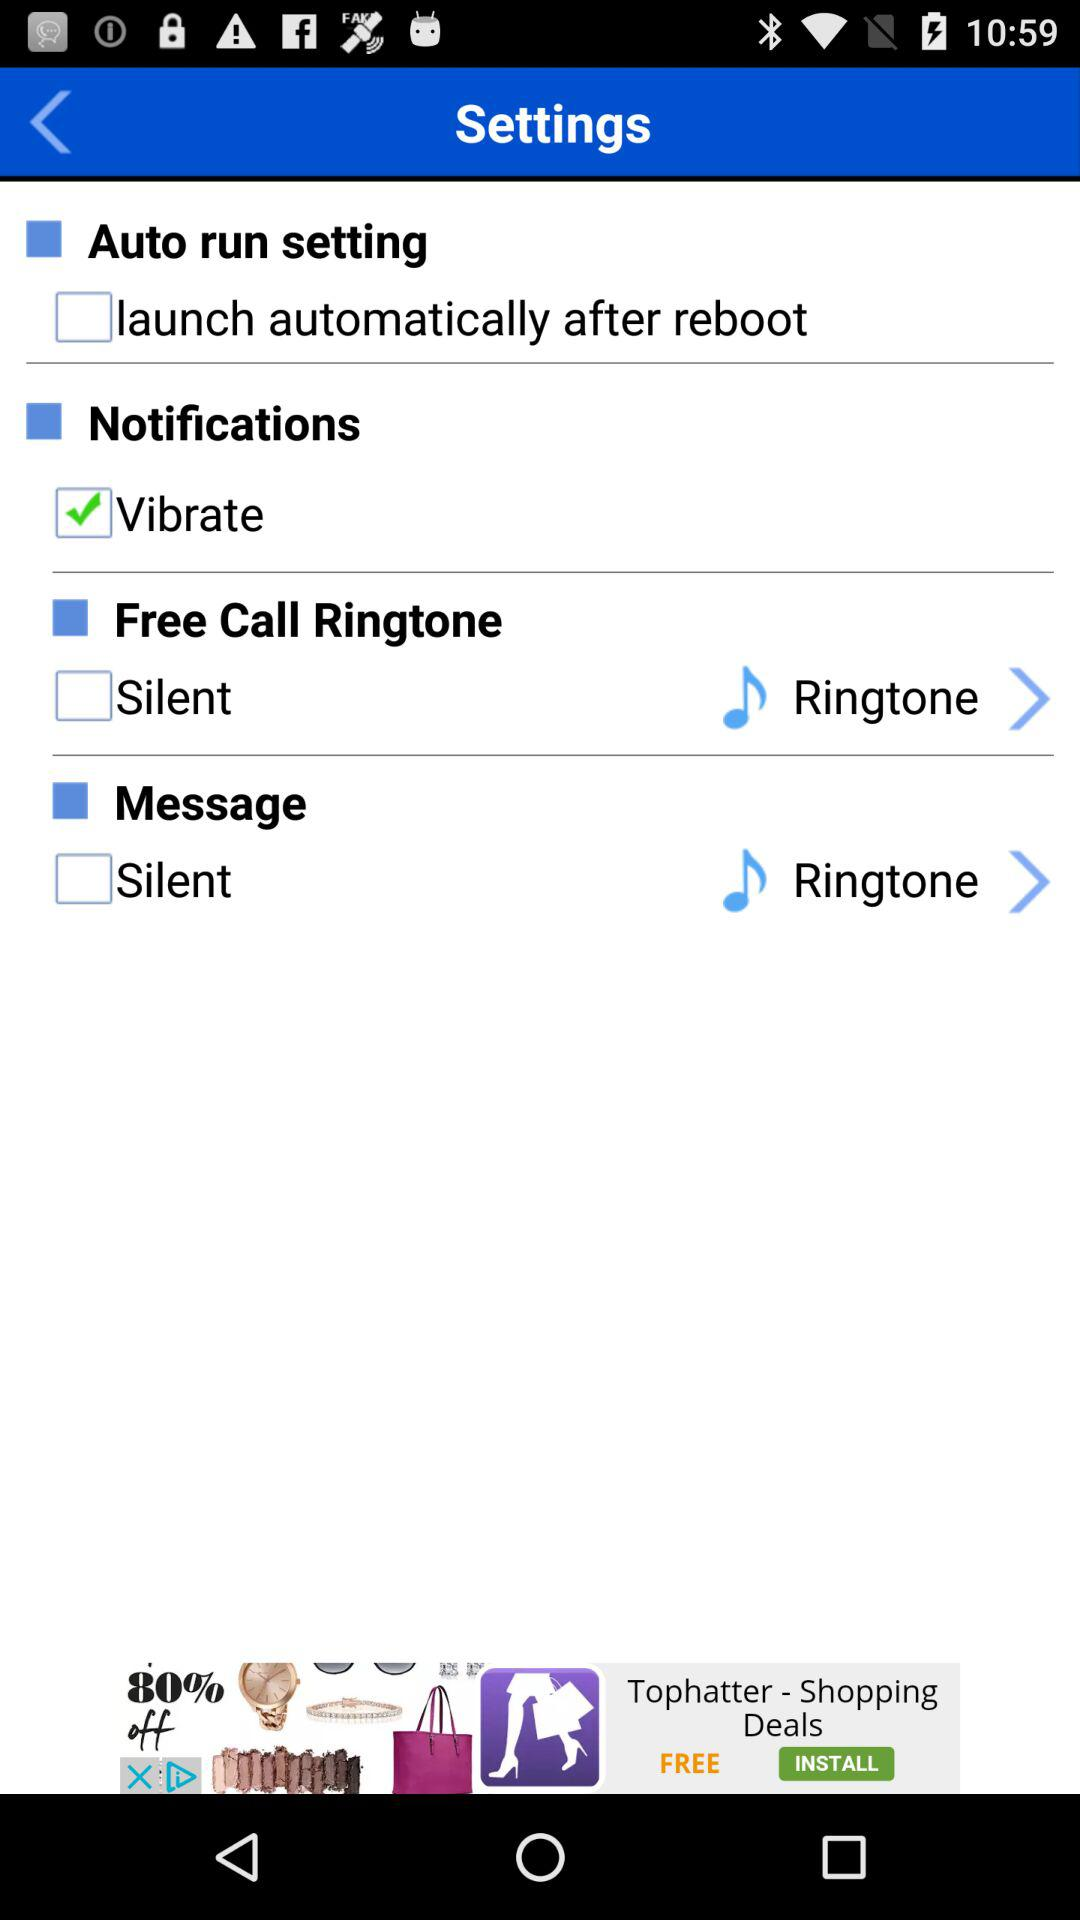Which version has been given? The version that has been given is 1.1.106. 